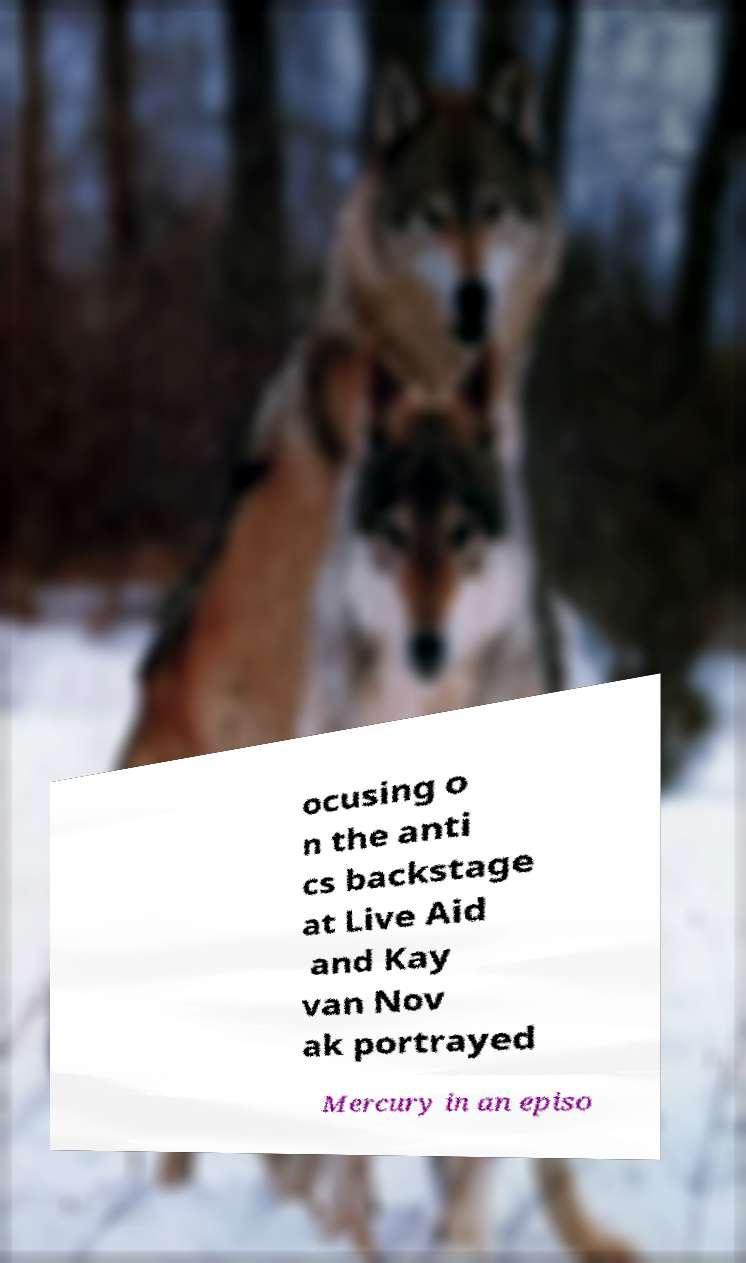Please identify and transcribe the text found in this image. ocusing o n the anti cs backstage at Live Aid and Kay van Nov ak portrayed Mercury in an episo 